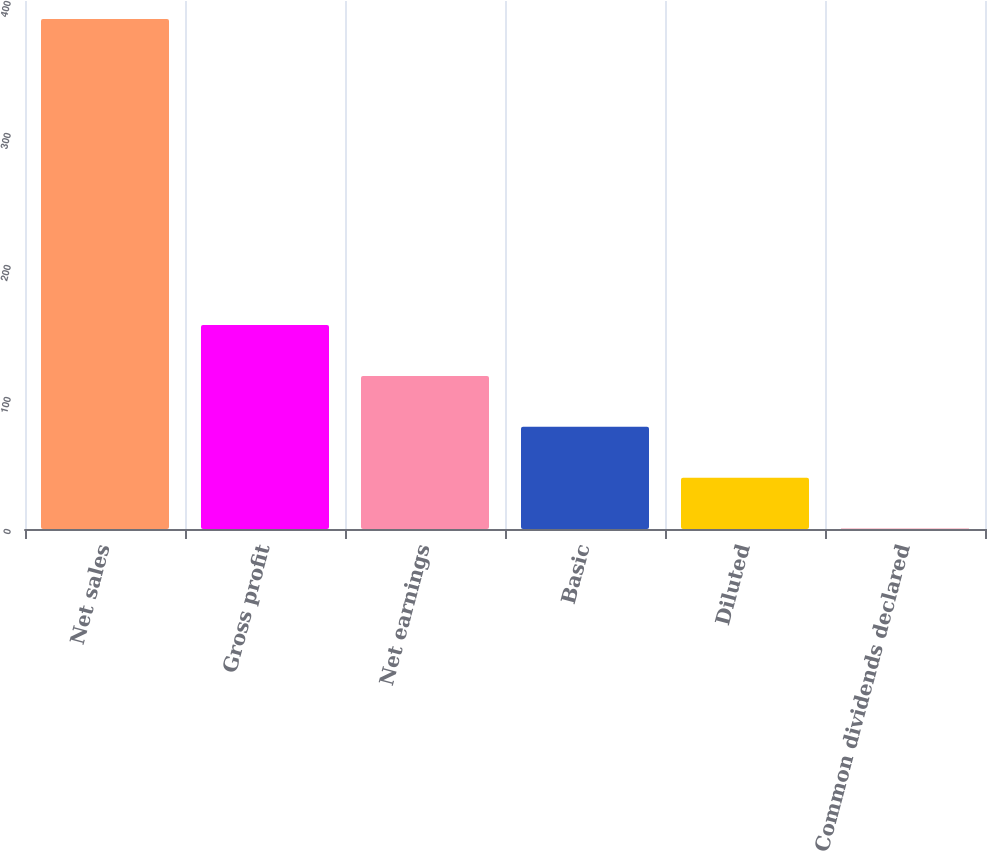Convert chart to OTSL. <chart><loc_0><loc_0><loc_500><loc_500><bar_chart><fcel>Net sales<fcel>Gross profit<fcel>Net earnings<fcel>Basic<fcel>Diluted<fcel>Common dividends declared<nl><fcel>386.3<fcel>154.61<fcel>115.99<fcel>77.37<fcel>38.75<fcel>0.13<nl></chart> 